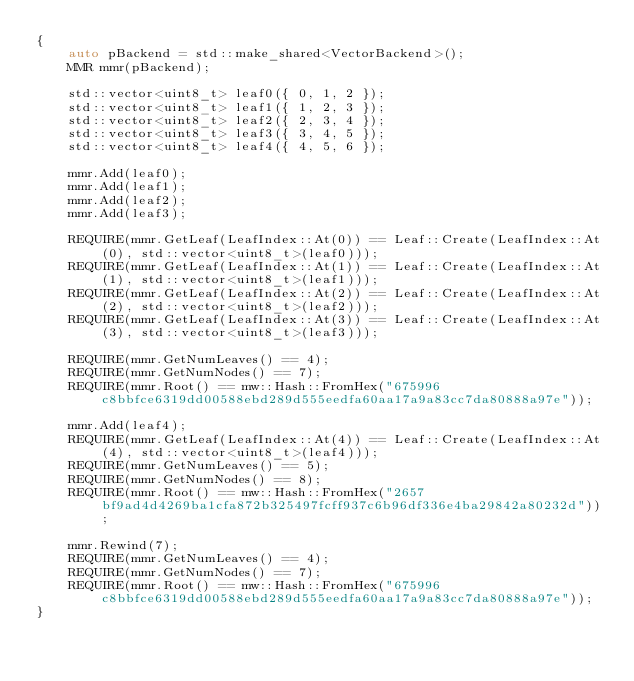<code> <loc_0><loc_0><loc_500><loc_500><_C++_>{
    auto pBackend = std::make_shared<VectorBackend>();
    MMR mmr(pBackend);

    std::vector<uint8_t> leaf0({ 0, 1, 2 });
    std::vector<uint8_t> leaf1({ 1, 2, 3 });
    std::vector<uint8_t> leaf2({ 2, 3, 4 });
    std::vector<uint8_t> leaf3({ 3, 4, 5 });
    std::vector<uint8_t> leaf4({ 4, 5, 6 });

    mmr.Add(leaf0);
    mmr.Add(leaf1);
    mmr.Add(leaf2);
    mmr.Add(leaf3);

    REQUIRE(mmr.GetLeaf(LeafIndex::At(0)) == Leaf::Create(LeafIndex::At(0), std::vector<uint8_t>(leaf0)));
    REQUIRE(mmr.GetLeaf(LeafIndex::At(1)) == Leaf::Create(LeafIndex::At(1), std::vector<uint8_t>(leaf1)));
    REQUIRE(mmr.GetLeaf(LeafIndex::At(2)) == Leaf::Create(LeafIndex::At(2), std::vector<uint8_t>(leaf2)));
    REQUIRE(mmr.GetLeaf(LeafIndex::At(3)) == Leaf::Create(LeafIndex::At(3), std::vector<uint8_t>(leaf3)));

    REQUIRE(mmr.GetNumLeaves() == 4);
    REQUIRE(mmr.GetNumNodes() == 7);
    REQUIRE(mmr.Root() == mw::Hash::FromHex("675996c8bbfce6319dd00588ebd289d555eedfa60aa17a9a83cc7da80888a97e"));

    mmr.Add(leaf4);
    REQUIRE(mmr.GetLeaf(LeafIndex::At(4)) == Leaf::Create(LeafIndex::At(4), std::vector<uint8_t>(leaf4)));
    REQUIRE(mmr.GetNumLeaves() == 5);
    REQUIRE(mmr.GetNumNodes() == 8);
    REQUIRE(mmr.Root() == mw::Hash::FromHex("2657bf9ad4d4269ba1cfa872b325497fcff937c6b96df336e4ba29842a80232d"));

    mmr.Rewind(7);
    REQUIRE(mmr.GetNumLeaves() == 4);
    REQUIRE(mmr.GetNumNodes() == 7);
    REQUIRE(mmr.Root() == mw::Hash::FromHex("675996c8bbfce6319dd00588ebd289d555eedfa60aa17a9a83cc7da80888a97e"));
}</code> 